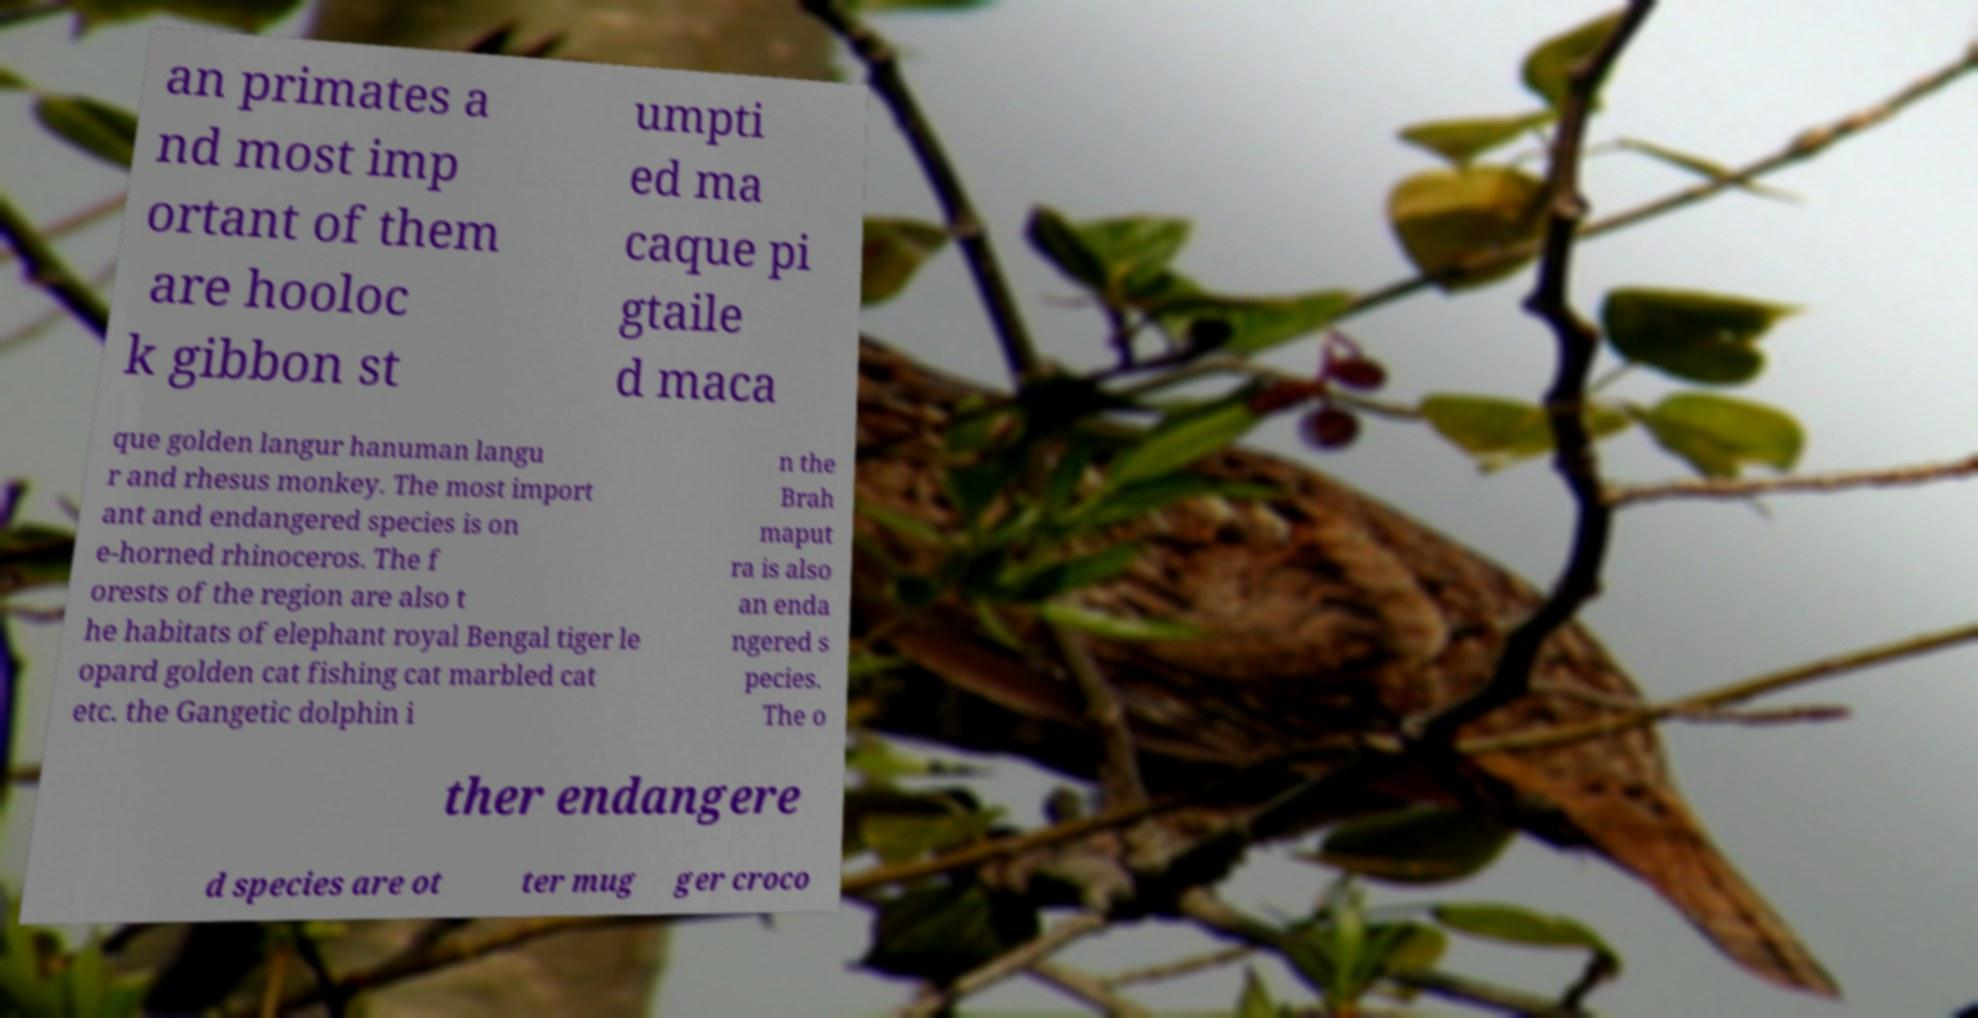I need the written content from this picture converted into text. Can you do that? an primates a nd most imp ortant of them are hooloc k gibbon st umpti ed ma caque pi gtaile d maca que golden langur hanuman langu r and rhesus monkey. The most import ant and endangered species is on e-horned rhinoceros. The f orests of the region are also t he habitats of elephant royal Bengal tiger le opard golden cat fishing cat marbled cat etc. the Gangetic dolphin i n the Brah maput ra is also an enda ngered s pecies. The o ther endangere d species are ot ter mug ger croco 